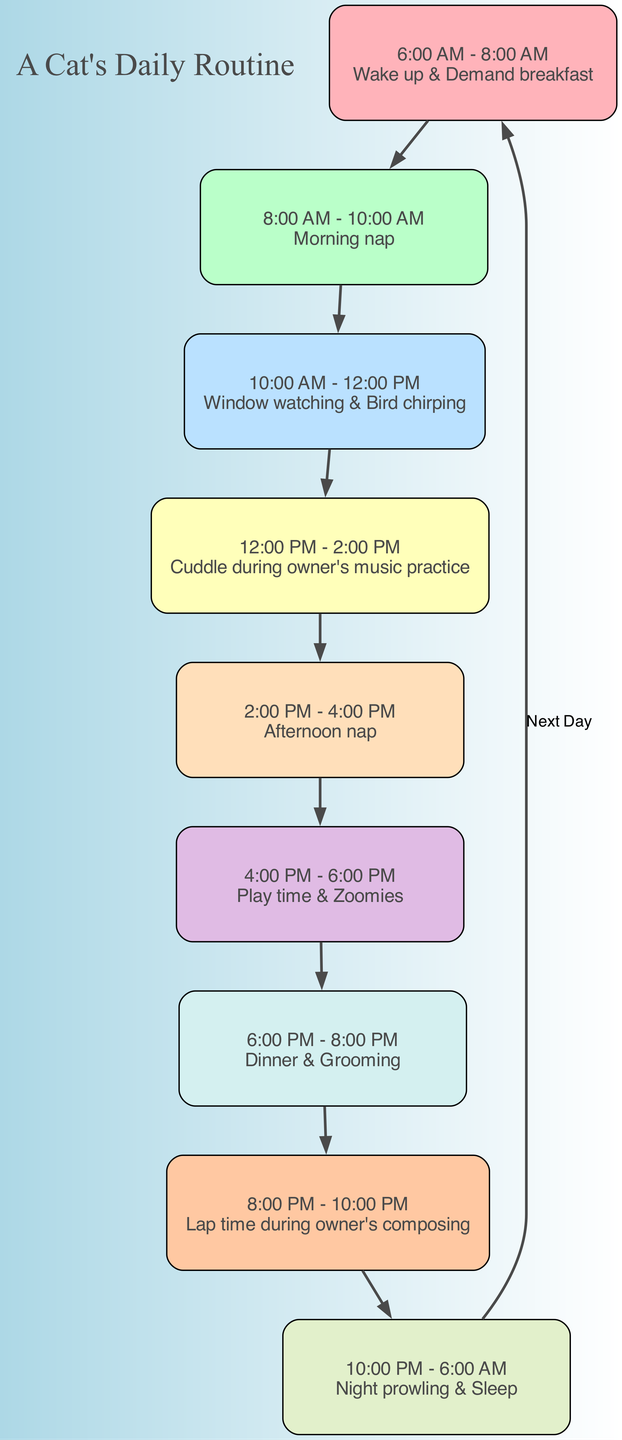What activity occurs from 10:00 AM to 12:00 PM? According to the diagram, during the time block of 10:00 AM to 12:00 PM, the activity listed is "Window watching & Bird chirping."
Answer: Window watching & Bird chirping How many activities are listed in the diagram? The diagram provides a total of 9 activities, as seen by counting each time block listed individually.
Answer: 9 What is the activity during the owner's music practice? From the diagram, during 12:00 PM to 2:00 PM, the activity is "Cuddle during owner's music practice."
Answer: Cuddle during owner's music practice Which activity has the longest continuous time block? By examining the time blocks, the activity "Night prowling & Sleep" spans from 10:00 PM to 6:00 AM, totaling 8 hours, making it the longest continuous time block.
Answer: Night prowling & Sleep What is the time block for playtime? The time block allocated for playtime is from 4:00 PM to 6:00 PM, as shown in the diagram under that specific activity.
Answer: 4:00 PM - 6:00 PM Which activity starts immediately after the evening grooming? The diagram shows that immediately after "Dinner & Grooming," from 8:00 PM to 10:00 PM, the activity is "Lap time during owner's composing."
Answer: Lap time during owner's composing How does the diagram connect the last activity back to the first? The diagram connects the last activity "Night prowling & Sleep" to the first activity "Wake up & Demand breakfast" with an edge labeled 'Next Day,' indicating a cyclical pattern.
Answer: Next Day What is the total time spent on naps throughout the day? Analyzing the blocks, the morning nap from 8:00 AM to 10:00 AM is 2 hours, and the afternoon nap from 2:00 PM to 4:00 PM is also 2 hours, totaling 4 hours of nap time.
Answer: 4 hours What color is the block for the activity "Dinner & Grooming"? Checking the associated colors in the diagram, the block for "Dinner & Grooming" from 6:00 PM to 8:00 PM is colored with one of the distinct color codes; it corresponds to the fifth color in the defined palette.
Answer: #FFDFBA 